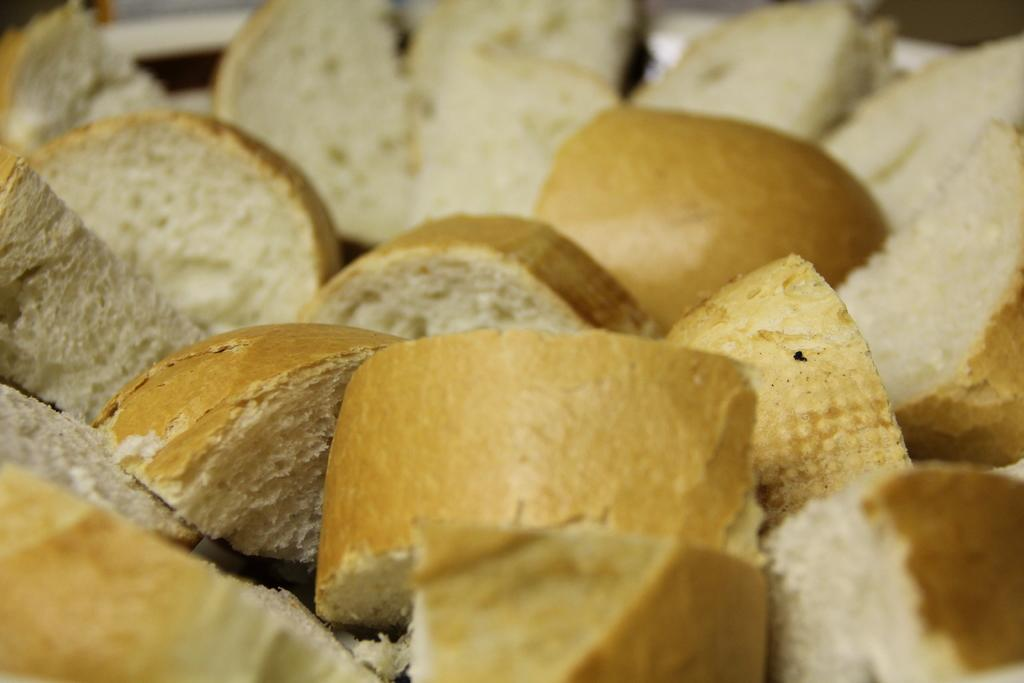What type of food can be seen in the image? There are pieces of bread in the image. Can you describe the background of the image? The background of the image is blurry. What type of jewel is being held by the sheep in the image? There is no sheep or jewel present in the image; it only features pieces of bread and a blurry background. 